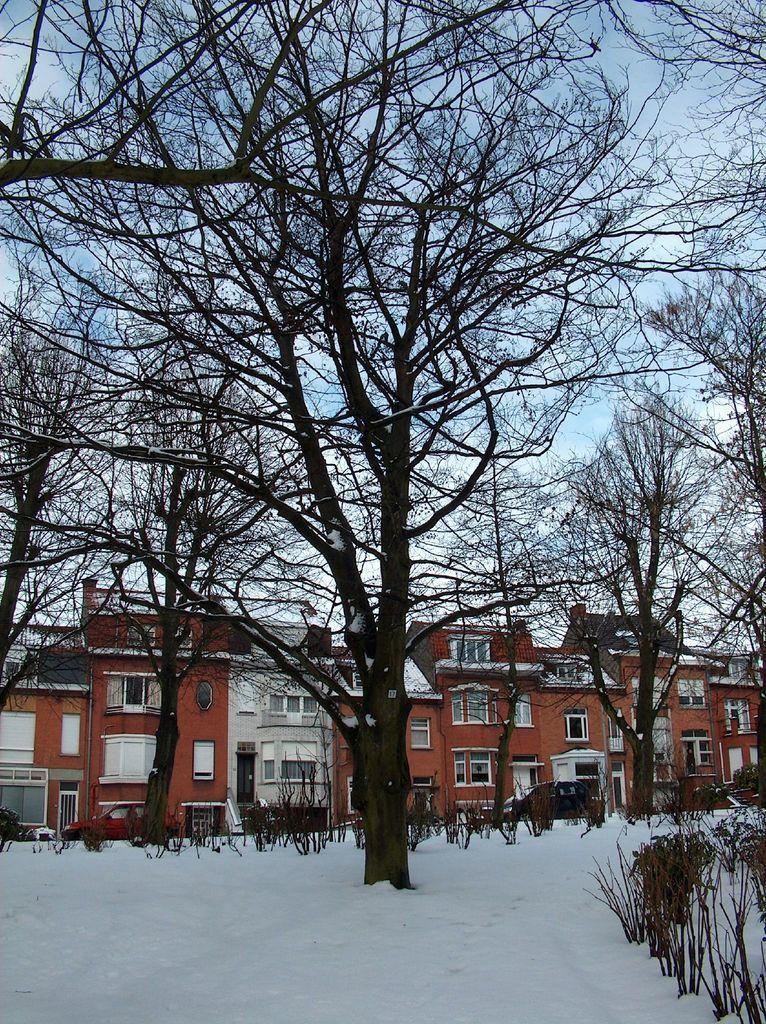Please provide a concise description of this image. On the right side, there are plants on the ground, on which there is snow. In the background, there are trees, plants, vehicles, buildings which are having windows and there are clouds in the blue sky. 